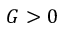<formula> <loc_0><loc_0><loc_500><loc_500>G > 0</formula> 